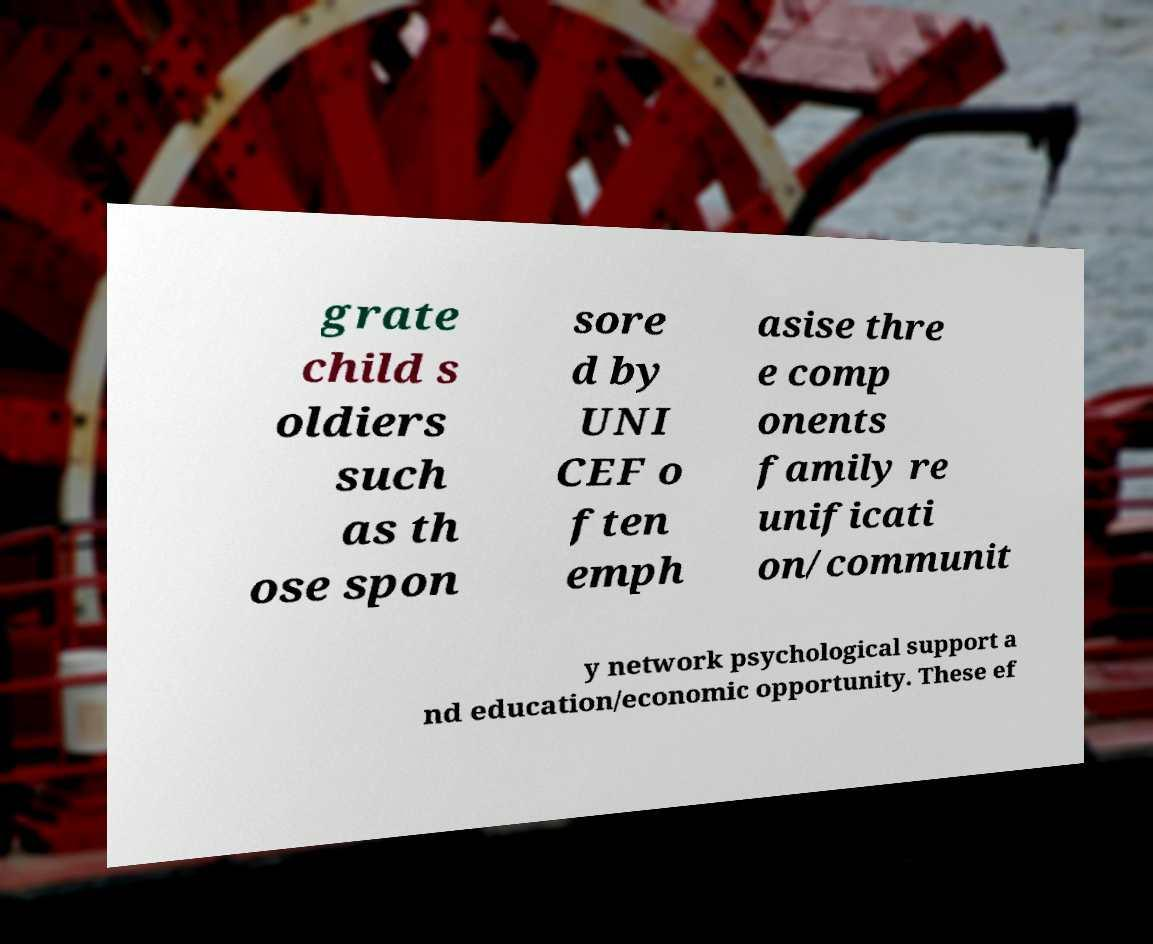Please identify and transcribe the text found in this image. grate child s oldiers such as th ose spon sore d by UNI CEF o ften emph asise thre e comp onents family re unificati on/communit y network psychological support a nd education/economic opportunity. These ef 